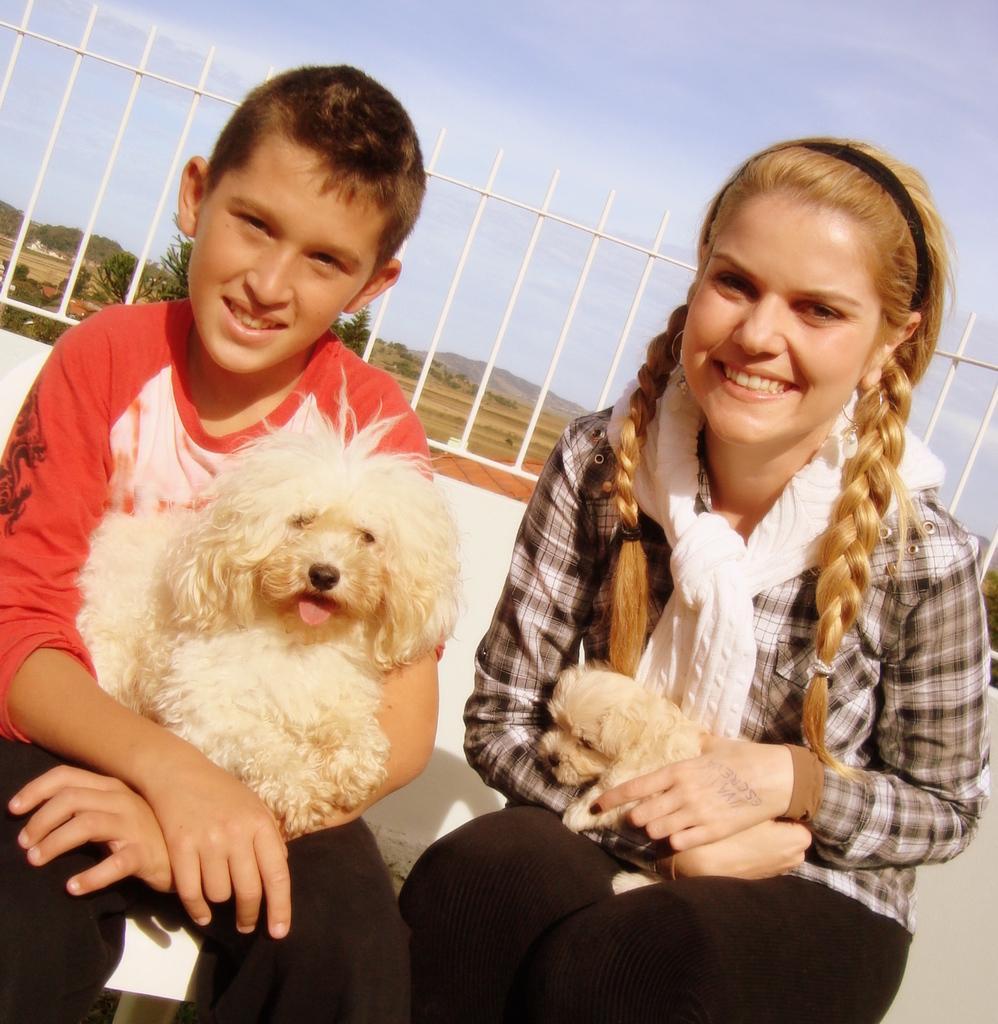Please provide a concise description of this image. In this picture we can see a man and a woman holding a dog with their hands. They are smiling. On the background we can see a sky. And there are some trees. 